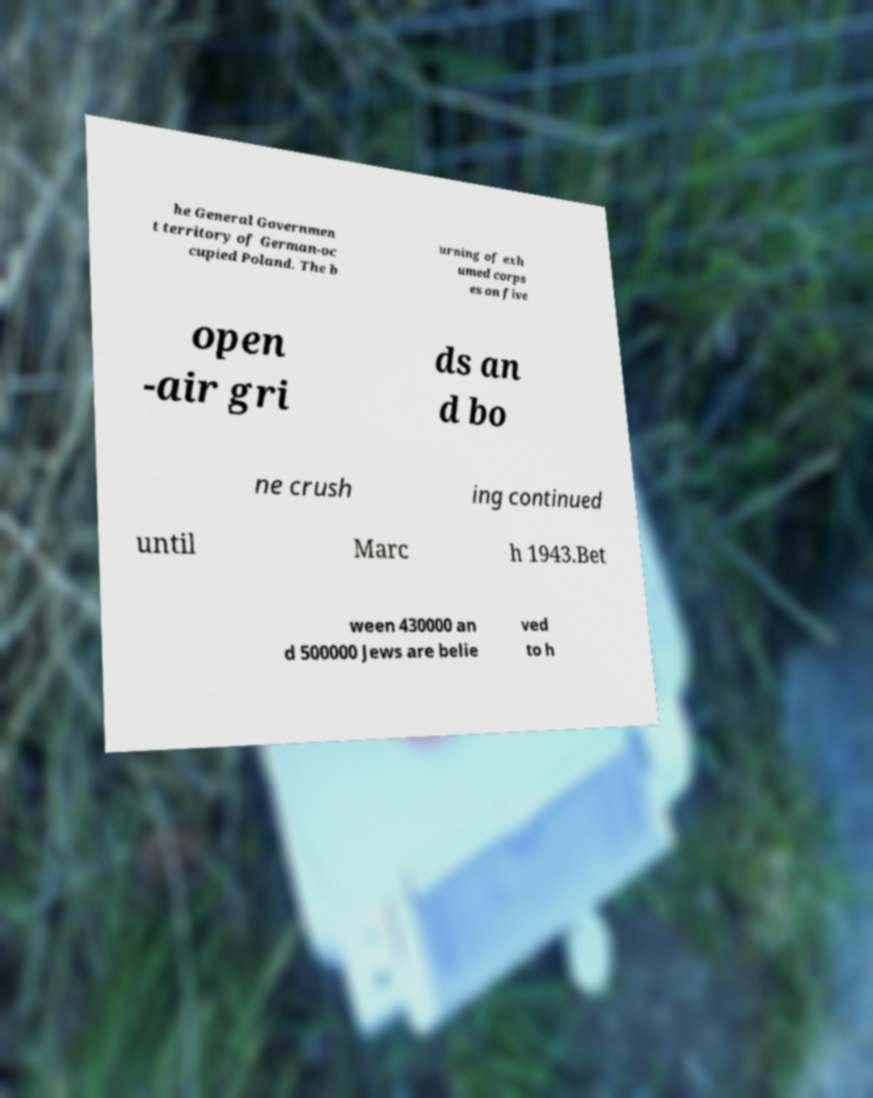Please identify and transcribe the text found in this image. he General Governmen t territory of German-oc cupied Poland. The b urning of exh umed corps es on five open -air gri ds an d bo ne crush ing continued until Marc h 1943.Bet ween 430000 an d 500000 Jews are belie ved to h 